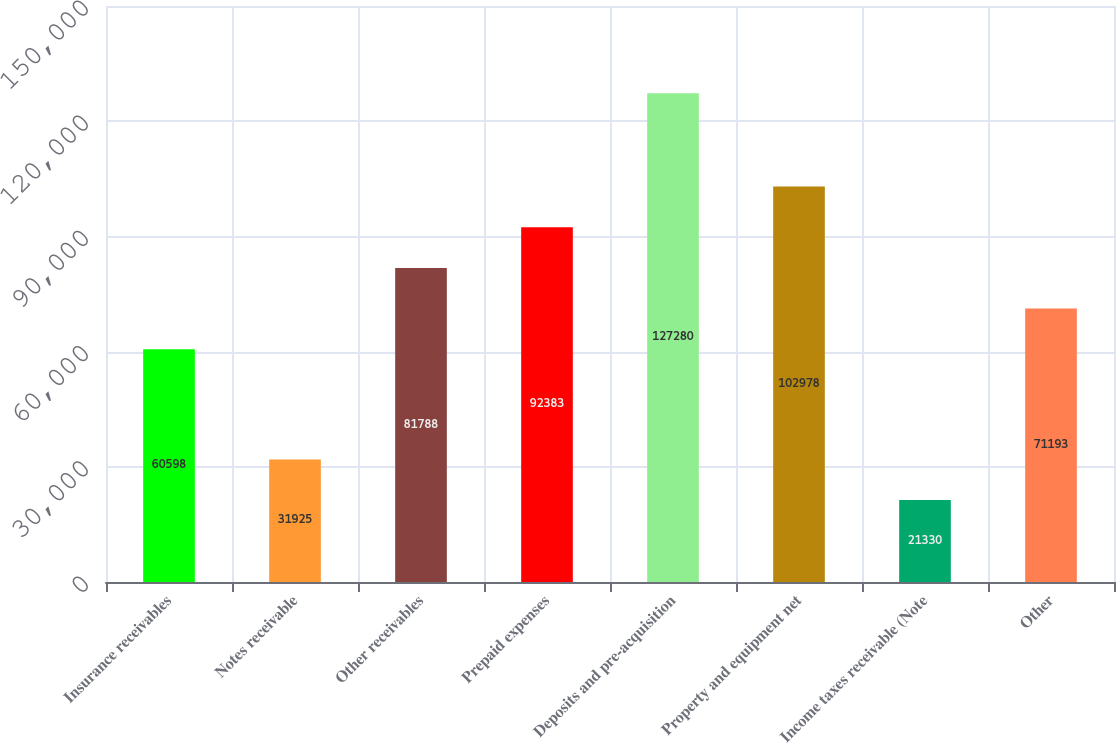Convert chart to OTSL. <chart><loc_0><loc_0><loc_500><loc_500><bar_chart><fcel>Insurance receivables<fcel>Notes receivable<fcel>Other receivables<fcel>Prepaid expenses<fcel>Deposits and pre-acquisition<fcel>Property and equipment net<fcel>Income taxes receivable (Note<fcel>Other<nl><fcel>60598<fcel>31925<fcel>81788<fcel>92383<fcel>127280<fcel>102978<fcel>21330<fcel>71193<nl></chart> 